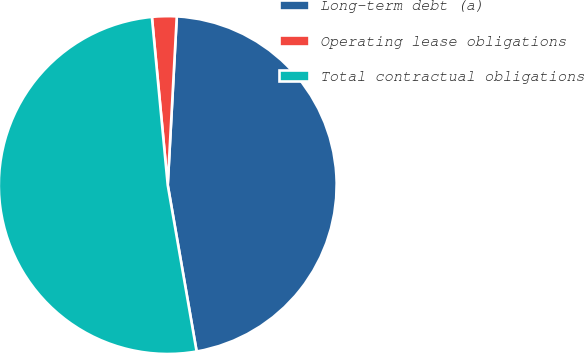Convert chart. <chart><loc_0><loc_0><loc_500><loc_500><pie_chart><fcel>Long-term debt (a)<fcel>Operating lease obligations<fcel>Total contractual obligations<nl><fcel>46.41%<fcel>2.35%<fcel>51.24%<nl></chart> 